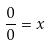<formula> <loc_0><loc_0><loc_500><loc_500>\frac { 0 } { 0 } = x</formula> 